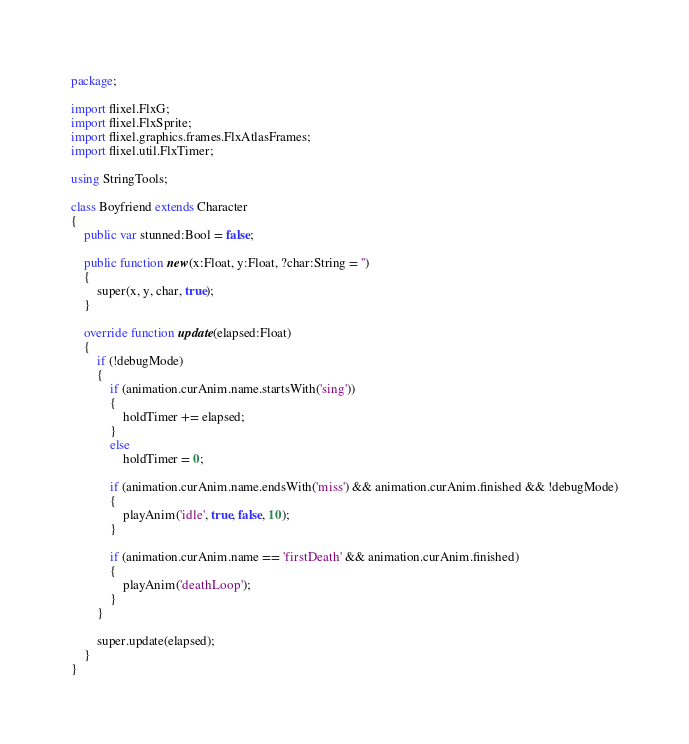<code> <loc_0><loc_0><loc_500><loc_500><_Haxe_>package;

import flixel.FlxG;
import flixel.FlxSprite;
import flixel.graphics.frames.FlxAtlasFrames;
import flixel.util.FlxTimer;

using StringTools;

class Boyfriend extends Character
{
	public var stunned:Bool = false;

	public function new(x:Float, y:Float, ?char:String = '')
	{
		super(x, y, char, true);
	}

	override function update(elapsed:Float)
	{
		if (!debugMode)
		{
			if (animation.curAnim.name.startsWith('sing'))
			{
				holdTimer += elapsed;
			}
			else
				holdTimer = 0;

			if (animation.curAnim.name.endsWith('miss') && animation.curAnim.finished && !debugMode)
			{
				playAnim('idle', true, false, 10);
			}

			if (animation.curAnim.name == 'firstDeath' && animation.curAnim.finished)
			{
				playAnim('deathLoop');
			}
		}

		super.update(elapsed);
	}
}
</code> 